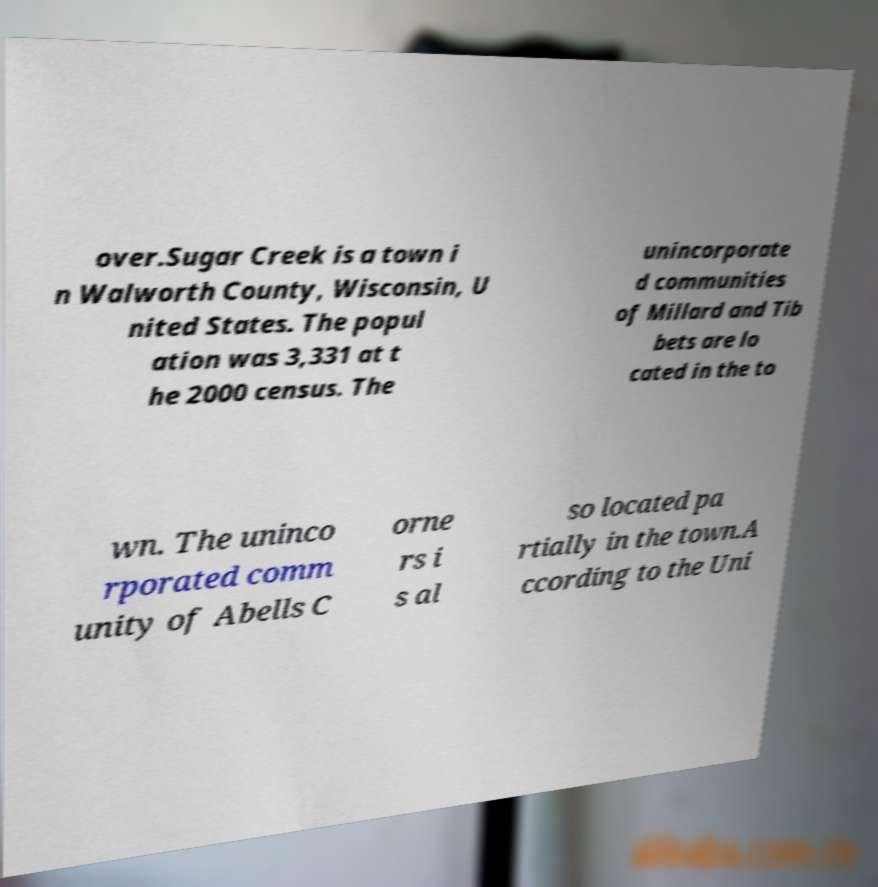Please read and relay the text visible in this image. What does it say? over.Sugar Creek is a town i n Walworth County, Wisconsin, U nited States. The popul ation was 3,331 at t he 2000 census. The unincorporate d communities of Millard and Tib bets are lo cated in the to wn. The uninco rporated comm unity of Abells C orne rs i s al so located pa rtially in the town.A ccording to the Uni 